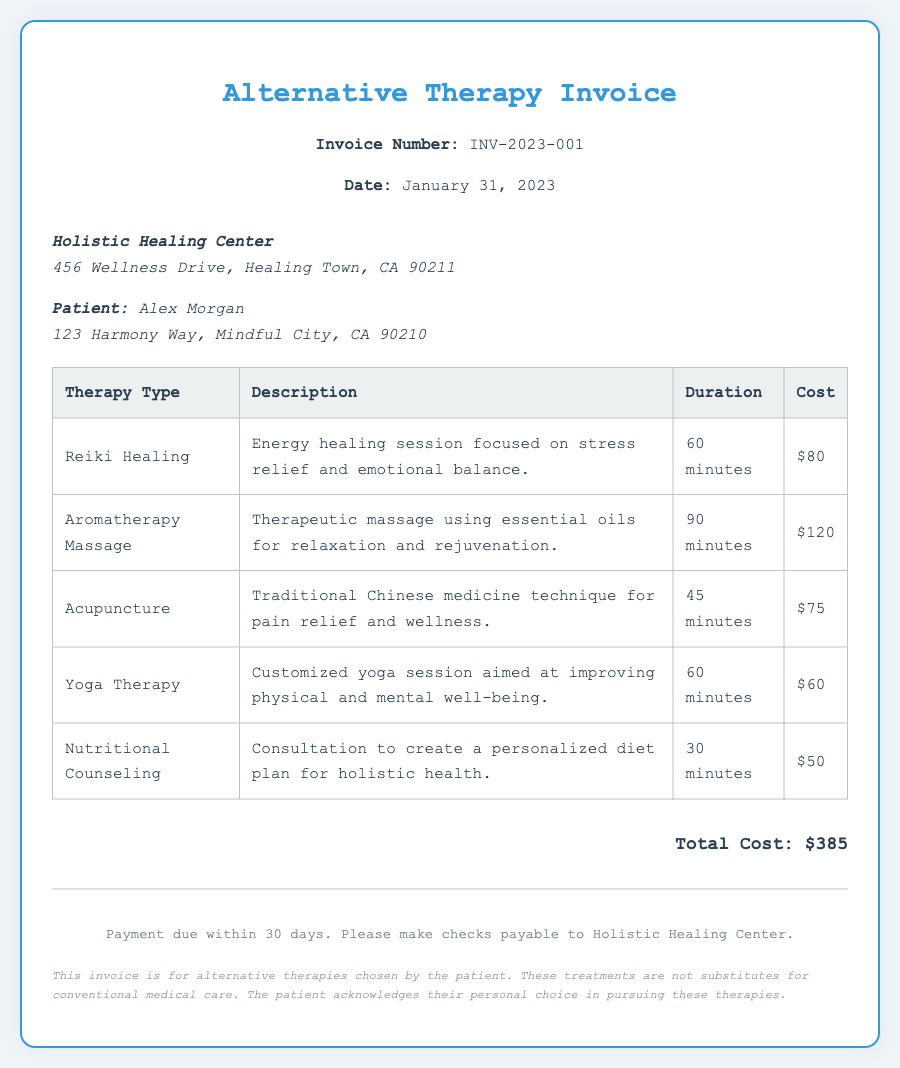What is the invoice number? The invoice number is explicitly mentioned in the document as INV-2023-001.
Answer: INV-2023-001 What is the total cost of the therapies? The total cost is calculated from the sum of all individual therapy costs listed in the document, which is $385.
Answer: $385 Who is the patient? The document identifies the patient as Alex Morgan.
Answer: Alex Morgan How long is the Reiki Healing session? The duration of the Reiki Healing session is stated as 60 minutes in the document.
Answer: 60 minutes What type of therapy includes essential oils? The therapy that includes essential oils is Aromatherapy Massage, as described in the invoice.
Answer: Aromatherapy Massage What is the address of the Holistic Healing Center? The address can be found in the header, listed as 456 Wellness Drive, Healing Town, CA 90211.
Answer: 456 Wellness Drive, Healing Town, CA 90211 How many types of therapies are listed? The document presents a total of 5 different types of therapies to choose from.
Answer: 5 When is the payment due? The payment due date is indicated as 30 days from the date of the invoice, which is January 31, 2023.
Answer: 30 days What is the duration of the Nutritional Counseling session? The Nutritional Counseling session duration is provided as 30 minutes in the document.
Answer: 30 minutes 